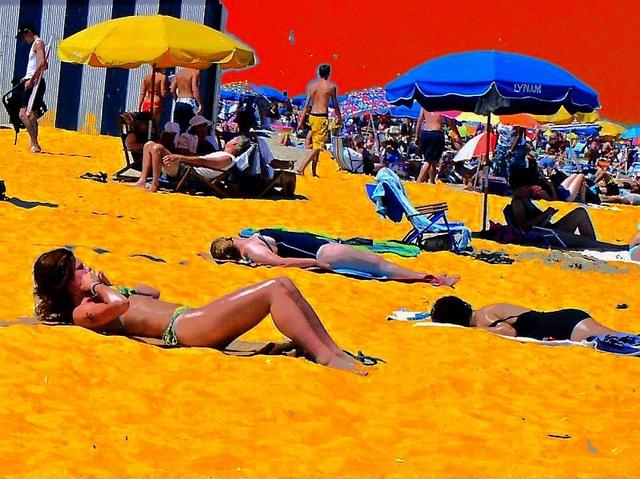What are the colors of umbrellas?
Be succinct. Yellow and blue. Has this photo been tinted?
Quick response, please. Yes. What color is the ground?
Keep it brief. Yellow. 